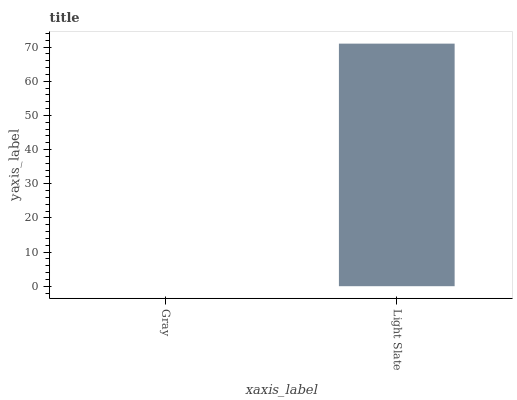Is Light Slate the minimum?
Answer yes or no. No. Is Light Slate greater than Gray?
Answer yes or no. Yes. Is Gray less than Light Slate?
Answer yes or no. Yes. Is Gray greater than Light Slate?
Answer yes or no. No. Is Light Slate less than Gray?
Answer yes or no. No. Is Light Slate the high median?
Answer yes or no. Yes. Is Gray the low median?
Answer yes or no. Yes. Is Gray the high median?
Answer yes or no. No. Is Light Slate the low median?
Answer yes or no. No. 